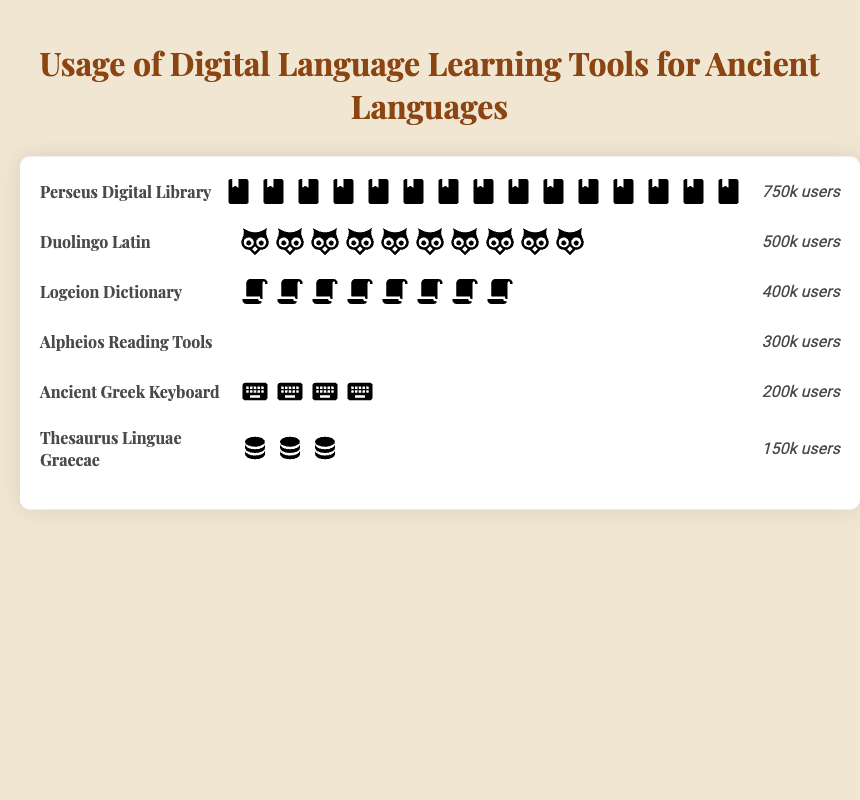Which digital language learning tool has the highest number of users? By observing the chart, we see that the Perseus Digital Library has the most icons, indicating it has the highest number of users.
Answer: Perseus Digital Library How many icons represent Duolingo Latin users? Each icon represents 50,000 users. Duolingo Latin has 500,000 users, so it is depicted by 500,000 / 50,000 = 10 icons.
Answer: 10 icons What is the total number of users for tools focusing on Latin? The two tools focusing on Latin are Duolingo Latin (500,000 users) and Logeion Dictionary (400,000 users). Adding them gives 500,000 + 400,000 = 900,000 users.
Answer: 900,000 Compare the number of users between the Alpheios Reading Tools and the Ancient Greek Keyboard. Which one has more users? The chart shows Alpheios Reading Tools with 300,000 users and the Ancient Greek Keyboard with 200,000 users. Therefore, Alpheios Reading Tools has more users.
Answer: Alpheios Reading Tools Which tool uses a scroll icon? By examining the icons associated with each tool, we identify Logeion Dictionary is represented by the scroll icon.
Answer: Logeion Dictionary What's the total number of users across all tools depicted in the chart? Adding the users from all listed tools: 500,000 (Duolingo Latin) + 750,000 (Perseus Digital Library) + 300,000 (Alpheios Reading Tools) + 200,000 (Ancient Greek Keyboard) + 400,000 (Logeion Dictionary) + 150,000 (Thesaurus Linguae Graecae) = 2,300,000 users.
Answer: 2,300,000 Which digital language learning tool has the least number of users? By identifying the tool with the fewest icons, we conclude that Thesaurus Linguae Graecae, with the lowest number (150,000 users), has the least number of users.
Answer: Thesaurus Linguae Graecae How many more users does the Perseus Digital Library have compared to the Thesaurus Linguae Graecae? We compare the users between Perseus Digital Library (750,000 users) and Thesaurus Linguae Graecae (150,000 users). The difference is 750,000 - 150,000 = 600,000 users.
Answer: 600,000 users Estimate the average number of users per tool depicted in the chart. The total number of users is 2,300,000 across 6 tools. The average is 2,300,000 / 6 ≈ 383,333 users per tool.
Answer: 383,333 users 